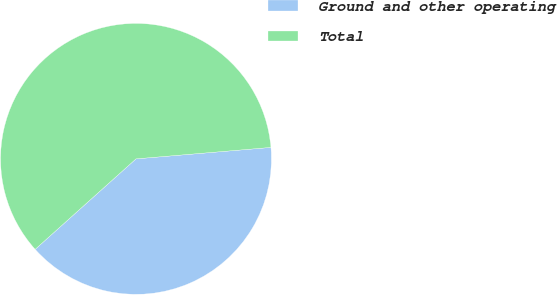<chart> <loc_0><loc_0><loc_500><loc_500><pie_chart><fcel>Ground and other operating<fcel>Total<nl><fcel>39.71%<fcel>60.29%<nl></chart> 